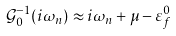<formula> <loc_0><loc_0><loc_500><loc_500>\mathcal { G } _ { 0 } ^ { - 1 } ( i \omega _ { n } ) \approx i \omega _ { n } + \mu - \varepsilon _ { f } ^ { 0 }</formula> 